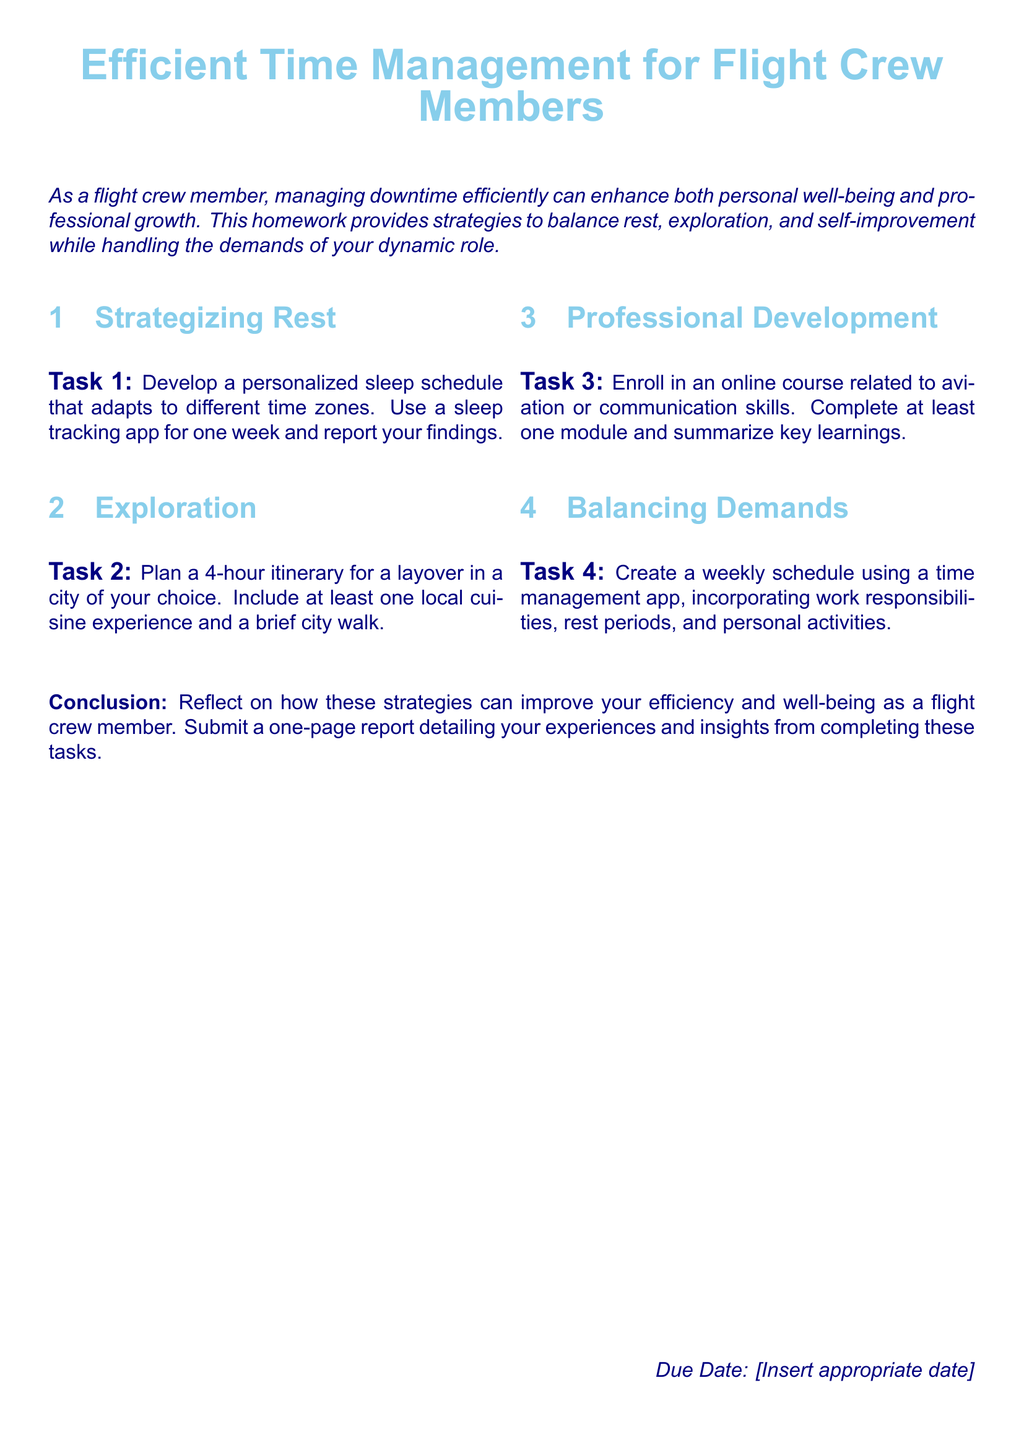what is the title of the document? The title of the document is prominently displayed at the top of the page as "Efficient Time Management for Flight Crew Members."
Answer: Efficient Time Management for Flight Crew Members what is the due date section labeled as? The due date section is labeled distinctly at the bottom right of the document.
Answer: Due Date how many tasks are outlined in the document? The document lists four tasks aimed at improving time management for flight crew members.
Answer: 4 what is the focus of Task 1? Task 1 focuses on developing a personalized sleep schedule adapted to different time zones, encouraging the use of a sleep tracking app.
Answer: Personalized sleep schedule what type of experience must be included in Task 2's itinerary? The itinerary for Task 2 must include a local cuisine experience during a layover.
Answer: Local cuisine experience what is the primary purpose of completing these tasks according to the conclusion? The conclusion emphasizes the improvement of efficiency and well-being as a goal for flight crew members through task completion.
Answer: Efficiency and well-being which section of the document involves professional growth? The section that specifically addresses professional growth is titled "Professional Development."
Answer: Professional Development how long should the report be at the conclusion of the homework? The report that is to be submitted should be one page detailing experiences and insights.
Answer: One page 